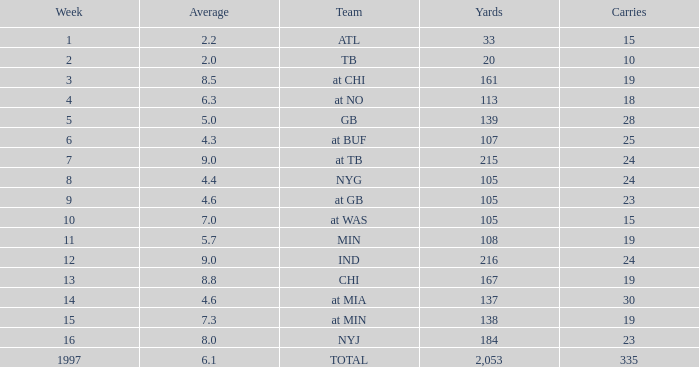Which Yards have Carries smaller than 23, and a Team of at chi, and an Average smaller than 8.5? None. 